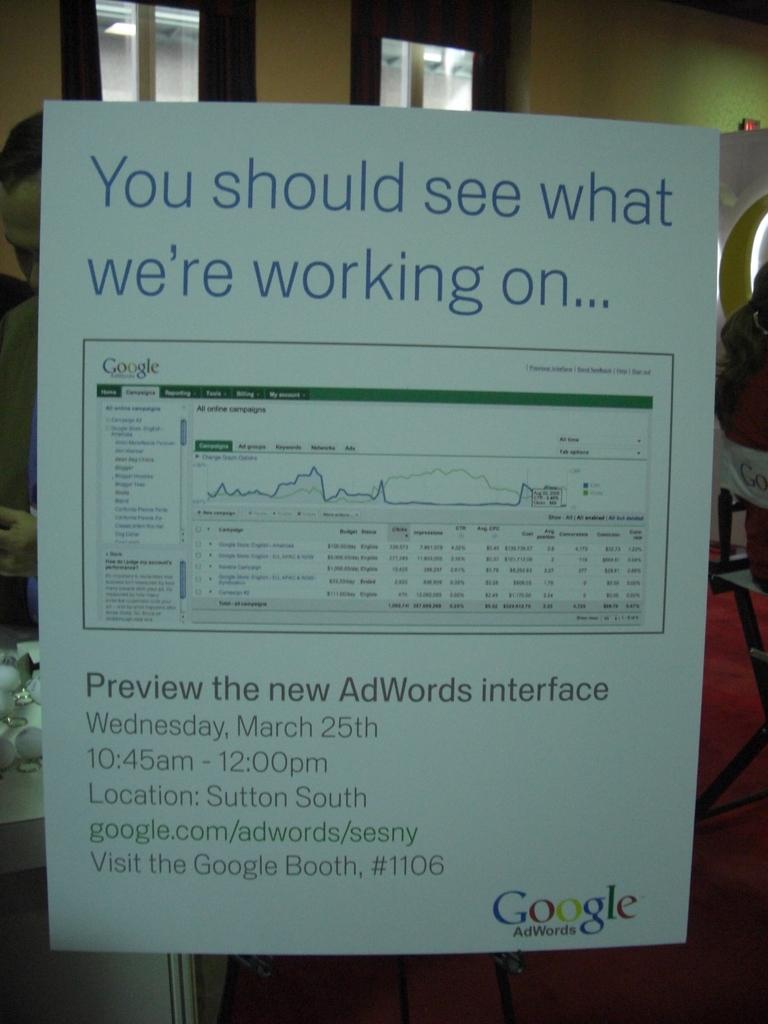Preview the new what?
Ensure brevity in your answer.  Adwords interface. I should see what?
Give a very brief answer. What we're working on. 